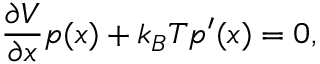Convert formula to latex. <formula><loc_0><loc_0><loc_500><loc_500>{ \frac { \partial V } { \partial x } } p ( x ) + { k _ { B } T } p ^ { \prime } ( x ) = 0 ,</formula> 